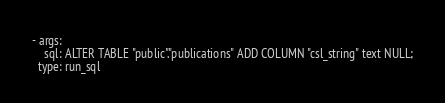<code> <loc_0><loc_0><loc_500><loc_500><_YAML_>- args:
    sql: ALTER TABLE "public"."publications" ADD COLUMN "csl_string" text NULL;
  type: run_sql
</code> 